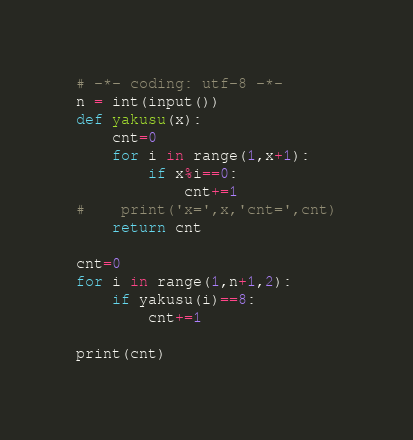Convert code to text. <code><loc_0><loc_0><loc_500><loc_500><_Python_># -*- coding: utf-8 -*-
n = int(input())
def yakusu(x):
    cnt=0
    for i in range(1,x+1):
        if x%i==0:
            cnt+=1
#    print('x=',x,'cnt=',cnt)
    return cnt

cnt=0
for i in range(1,n+1,2):
    if yakusu(i)==8:
        cnt+=1

print(cnt)</code> 